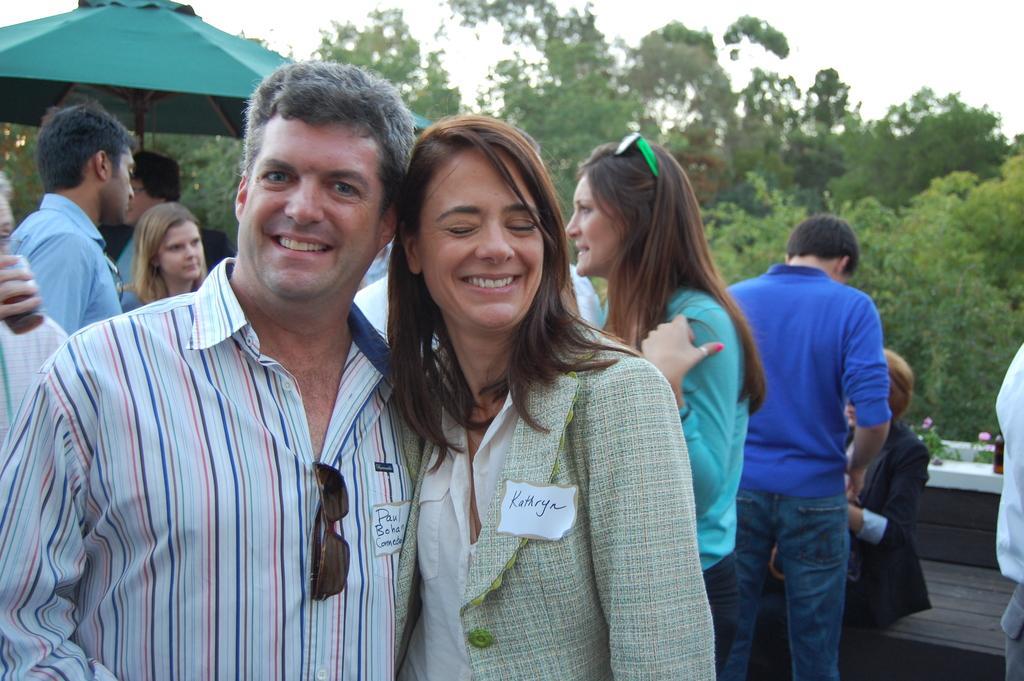Describe this image in one or two sentences. In this image we can see a few people, there are some trees, plants with flowers and a bottle, also we can see an umbrella, in the background, we can see the sky. 